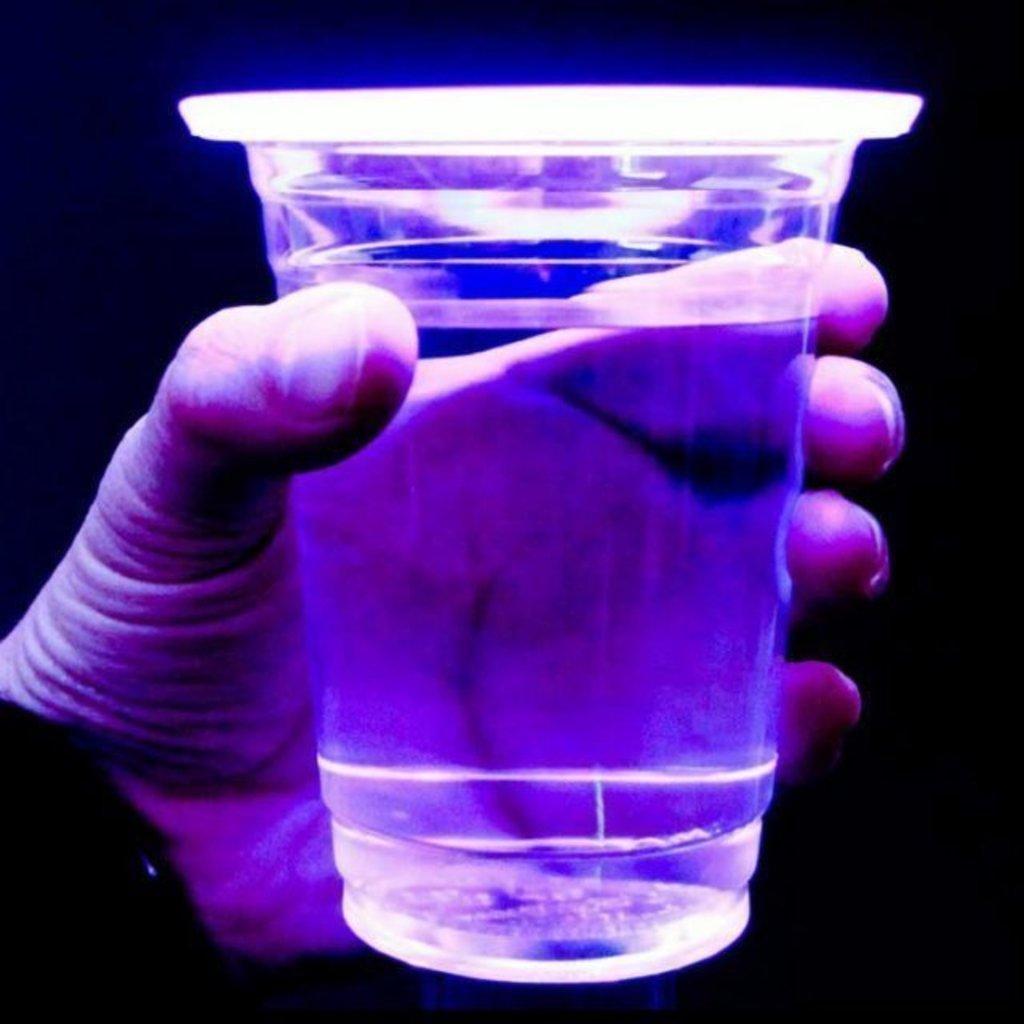Describe this image in one or two sentences. In this image on the left side there is a person hand which is holding a glass, contain a liquid, background is dark. 